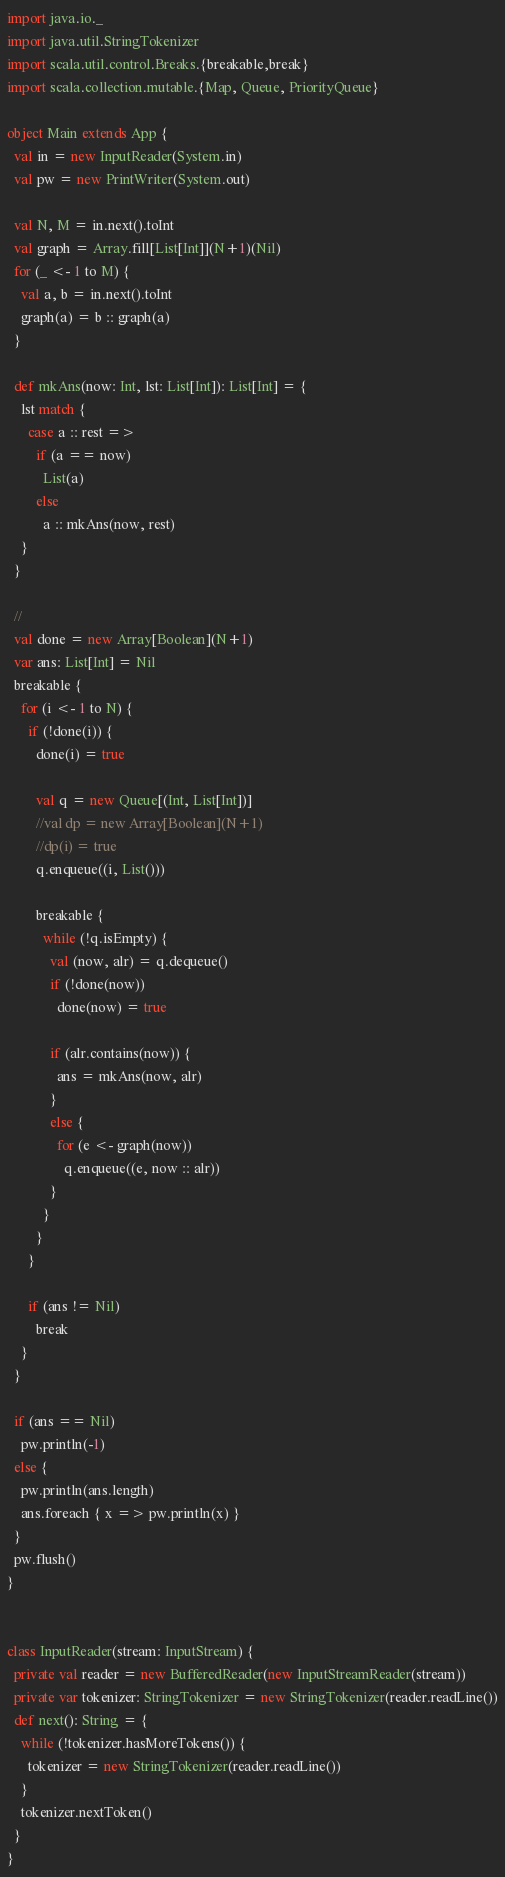Convert code to text. <code><loc_0><loc_0><loc_500><loc_500><_Scala_>import java.io._
import java.util.StringTokenizer
import scala.util.control.Breaks.{breakable,break}
import scala.collection.mutable.{Map, Queue, PriorityQueue}

object Main extends App {
  val in = new InputReader(System.in)
  val pw = new PrintWriter(System.out)

  val N, M = in.next().toInt
  val graph = Array.fill[List[Int]](N+1)(Nil)
  for (_ <- 1 to M) {
    val a, b = in.next().toInt
    graph(a) = b :: graph(a)
  }

  def mkAns(now: Int, lst: List[Int]): List[Int] = {
    lst match {
      case a :: rest =>
        if (a == now)
          List(a)
        else
          a :: mkAns(now, rest)
    }
  }

  //
  val done = new Array[Boolean](N+1)
  var ans: List[Int] = Nil
  breakable {
    for (i <- 1 to N) {
      if (!done(i)) {
        done(i) = true

        val q = new Queue[(Int, List[Int])]
        //val dp = new Array[Boolean](N+1)
        //dp(i) = true
        q.enqueue((i, List()))

        breakable {
          while (!q.isEmpty) {
            val (now, alr) = q.dequeue()
            if (!done(now))
              done(now) = true

            if (alr.contains(now)) {
              ans = mkAns(now, alr)
            }
            else {
              for (e <- graph(now))
                q.enqueue((e, now :: alr))
            }
          }
        }
      }

      if (ans != Nil)
        break
    }
  }

  if (ans == Nil)
    pw.println(-1)
  else {
    pw.println(ans.length)
    ans.foreach { x => pw.println(x) }
  }
  pw.flush()
}


class InputReader(stream: InputStream) {
  private val reader = new BufferedReader(new InputStreamReader(stream))
  private var tokenizer: StringTokenizer = new StringTokenizer(reader.readLine())
  def next(): String = {
    while (!tokenizer.hasMoreTokens()) {
      tokenizer = new StringTokenizer(reader.readLine())
    }
    tokenizer.nextToken()
  }
}
</code> 